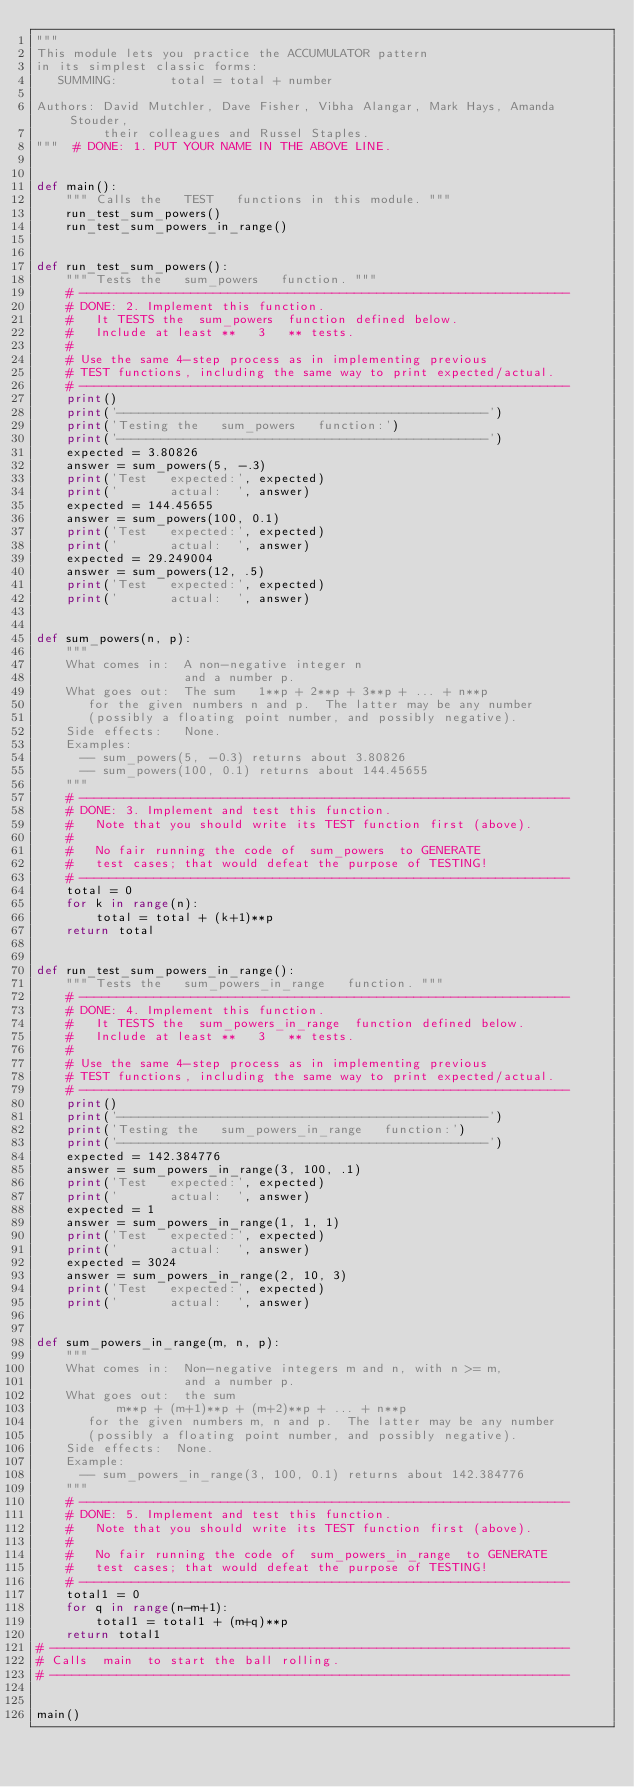Convert code to text. <code><loc_0><loc_0><loc_500><loc_500><_Python_>"""
This module lets you practice the ACCUMULATOR pattern
in its simplest classic forms:
   SUMMING:       total = total + number

Authors: David Mutchler, Dave Fisher, Vibha Alangar, Mark Hays, Amanda Stouder,
         their colleagues and Russel Staples.
"""  # DONE: 1. PUT YOUR NAME IN THE ABOVE LINE.


def main():
    """ Calls the   TEST   functions in this module. """
    run_test_sum_powers()
    run_test_sum_powers_in_range()


def run_test_sum_powers():
    """ Tests the   sum_powers   function. """
    # ------------------------------------------------------------------
    # DONE: 2. Implement this function.
    #   It TESTS the  sum_powers  function defined below.
    #   Include at least **   3   ** tests.
    #
    # Use the same 4-step process as in implementing previous
    # TEST functions, including the same way to print expected/actual.
    # ------------------------------------------------------------------
    print()
    print('--------------------------------------------------')
    print('Testing the   sum_powers   function:')
    print('--------------------------------------------------')
    expected = 3.80826
    answer = sum_powers(5, -.3)
    print('Test   expected:', expected)
    print('       actual:  ', answer)
    expected = 144.45655
    answer = sum_powers(100, 0.1)
    print('Test   expected:', expected)
    print('       actual:  ', answer)
    expected = 29.249004
    answer = sum_powers(12, .5)
    print('Test   expected:', expected)
    print('       actual:  ', answer)


def sum_powers(n, p):
    """
    What comes in:  A non-negative integer n
                    and a number p.
    What goes out:  The sum   1**p + 2**p + 3**p + ... + n**p
       for the given numbers n and p.  The latter may be any number
       (possibly a floating point number, and possibly negative).
    Side effects:   None.
    Examples:
      -- sum_powers(5, -0.3) returns about 3.80826
      -- sum_powers(100, 0.1) returns about 144.45655
    """
    # ------------------------------------------------------------------
    # DONE: 3. Implement and test this function.
    #   Note that you should write its TEST function first (above).
    #
    #   No fair running the code of  sum_powers  to GENERATE
    #   test cases; that would defeat the purpose of TESTING!
    # ------------------------------------------------------------------
    total = 0
    for k in range(n):
        total = total + (k+1)**p
    return total


def run_test_sum_powers_in_range():
    """ Tests the   sum_powers_in_range   function. """
    # ------------------------------------------------------------------
    # DONE: 4. Implement this function.
    #   It TESTS the  sum_powers_in_range  function defined below.
    #   Include at least **   3   ** tests.
    #
    # Use the same 4-step process as in implementing previous
    # TEST functions, including the same way to print expected/actual.
    # ------------------------------------------------------------------
    print()
    print('--------------------------------------------------')
    print('Testing the   sum_powers_in_range   function:')
    print('--------------------------------------------------')
    expected = 142.384776
    answer = sum_powers_in_range(3, 100, .1)
    print('Test   expected:', expected)
    print('       actual:  ', answer)
    expected = 1
    answer = sum_powers_in_range(1, 1, 1)
    print('Test   expected:', expected)
    print('       actual:  ', answer)
    expected = 3024
    answer = sum_powers_in_range(2, 10, 3)
    print('Test   expected:', expected)
    print('       actual:  ', answer)


def sum_powers_in_range(m, n, p):
    """
    What comes in:  Non-negative integers m and n, with n >= m,
                    and a number p.
    What goes out:  the sum
           m**p + (m+1)**p + (m+2)**p + ... + n**p
       for the given numbers m, n and p.  The latter may be any number
       (possibly a floating point number, and possibly negative).
    Side effects:  None.
    Example:
      -- sum_powers_in_range(3, 100, 0.1) returns about 142.384776
    """
    # ------------------------------------------------------------------
    # DONE: 5. Implement and test this function.
    #   Note that you should write its TEST function first (above).
    #
    #   No fair running the code of  sum_powers_in_range  to GENERATE
    #   test cases; that would defeat the purpose of TESTING!
    # ------------------------------------------------------------------
    total1 = 0
    for q in range(n-m+1):
        total1 = total1 + (m+q)**p
    return total1
# ----------------------------------------------------------------------
# Calls  main  to start the ball rolling.
# ----------------------------------------------------------------------


main()
</code> 